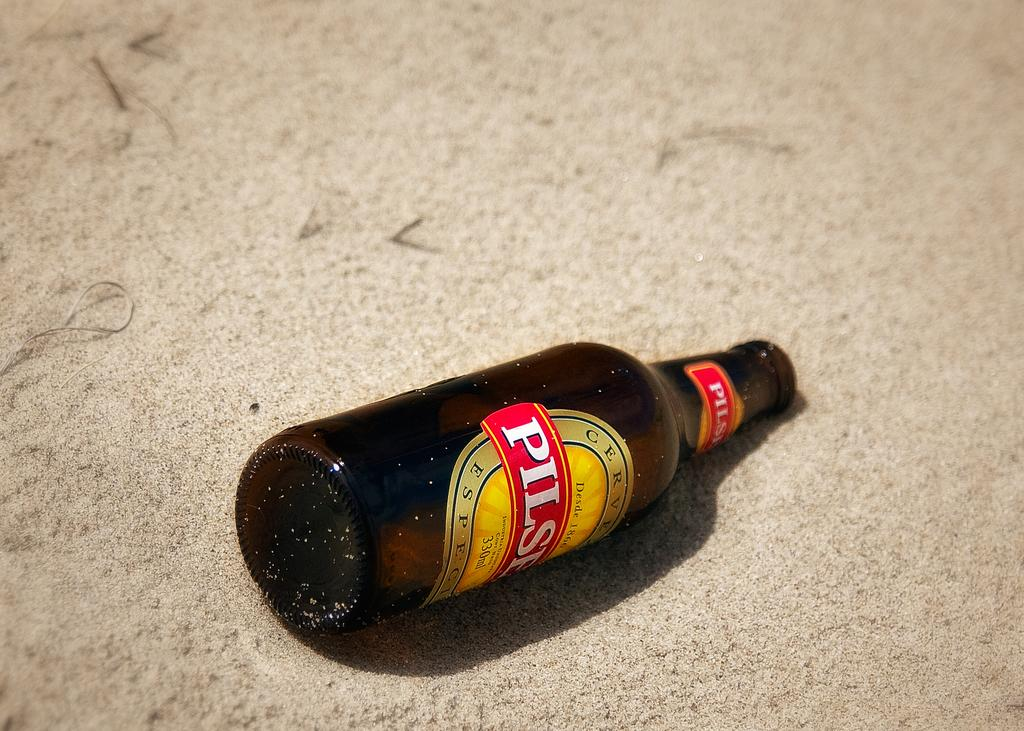<image>
Write a terse but informative summary of the picture. A bottle of Pilsner lays down on the ground. 